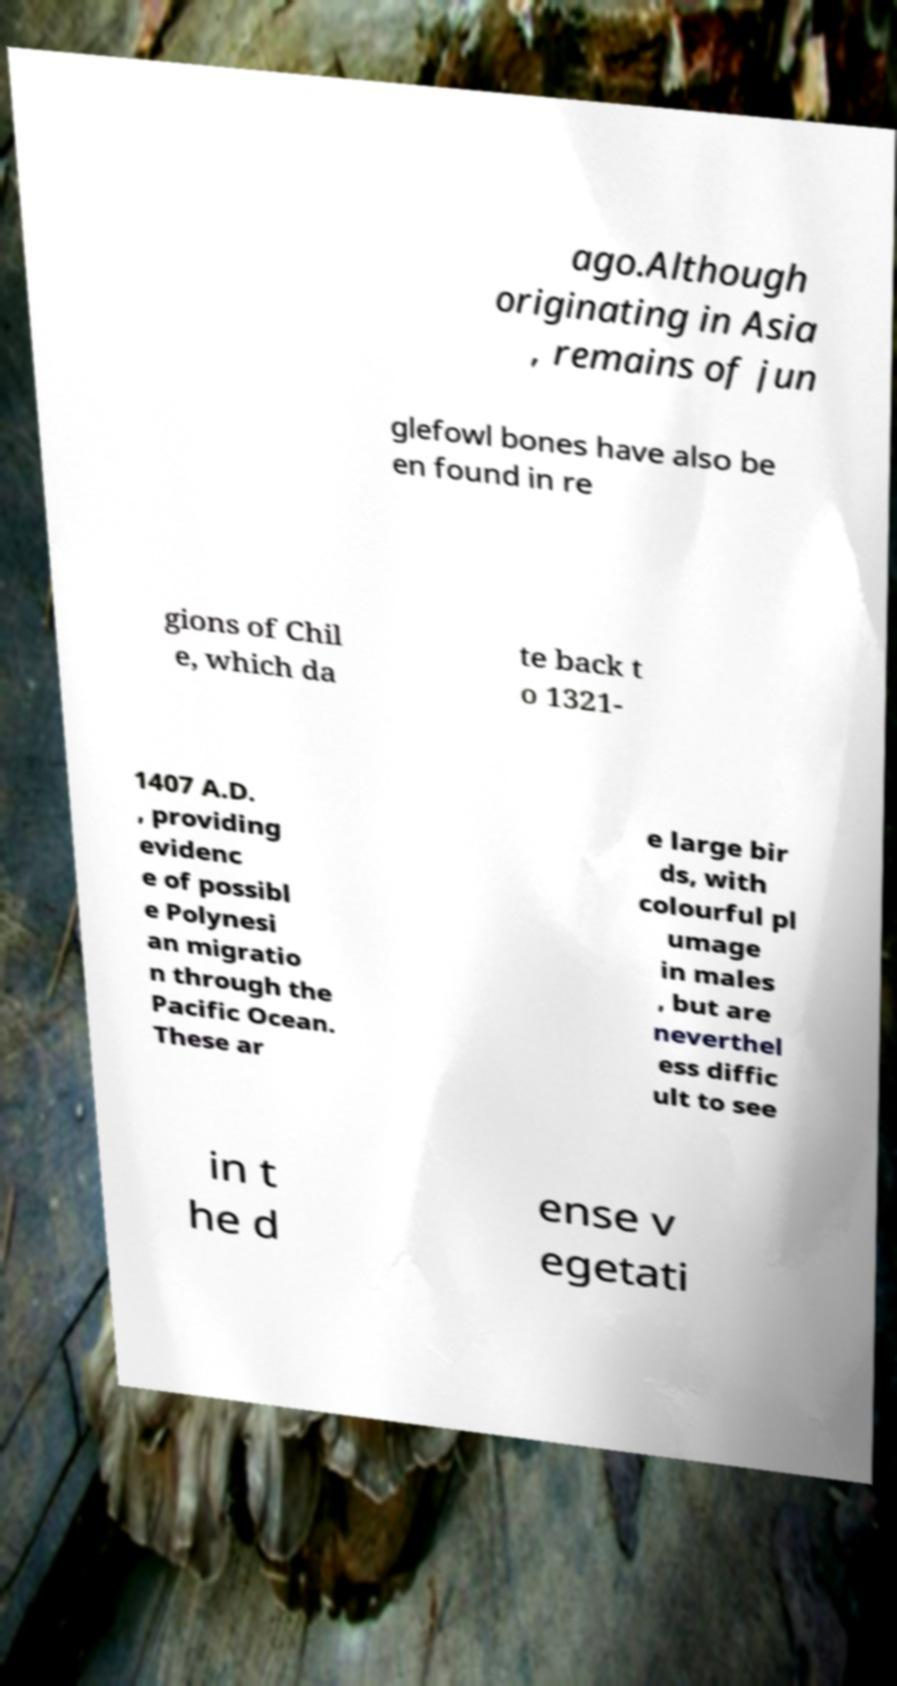Can you read and provide the text displayed in the image?This photo seems to have some interesting text. Can you extract and type it out for me? ago.Although originating in Asia , remains of jun glefowl bones have also be en found in re gions of Chil e, which da te back t o 1321- 1407 A.D. , providing evidenc e of possibl e Polynesi an migratio n through the Pacific Ocean. These ar e large bir ds, with colourful pl umage in males , but are neverthel ess diffic ult to see in t he d ense v egetati 